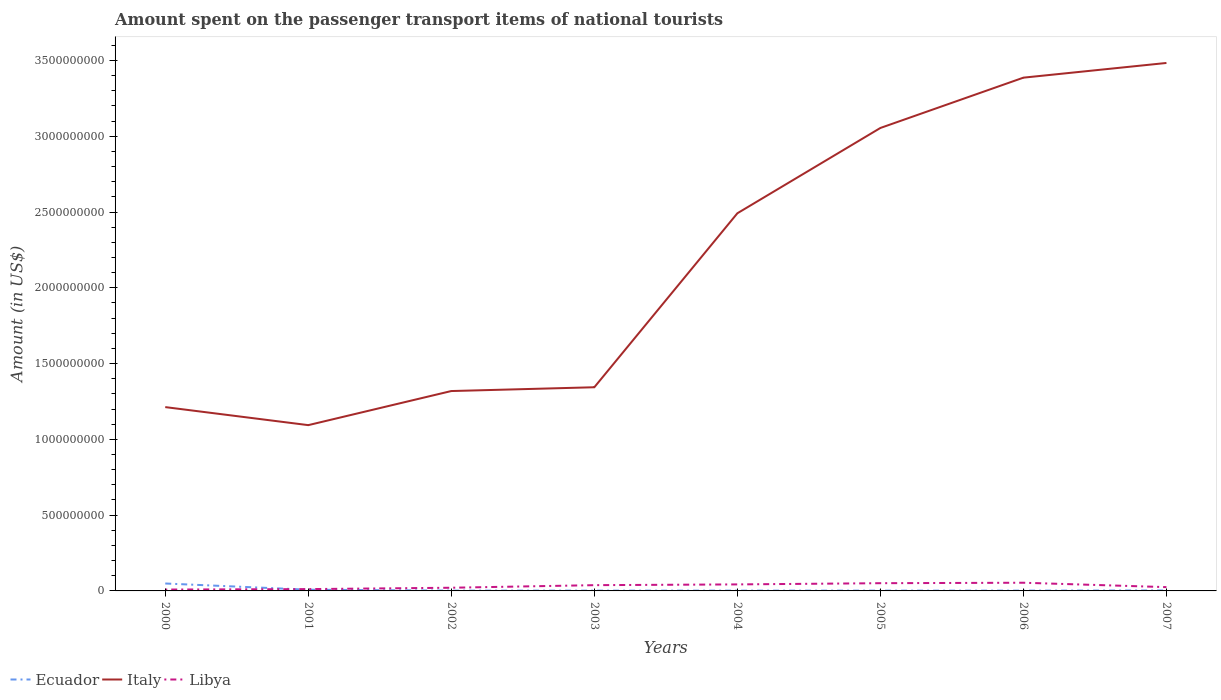Does the line corresponding to Libya intersect with the line corresponding to Italy?
Your answer should be very brief. No. Is the number of lines equal to the number of legend labels?
Your answer should be very brief. Yes. Across all years, what is the maximum amount spent on the passenger transport items of national tourists in Ecuador?
Give a very brief answer. 2.00e+06. What is the total amount spent on the passenger transport items of national tourists in Ecuador in the graph?
Keep it short and to the point. 6.00e+06. What is the difference between the highest and the second highest amount spent on the passenger transport items of national tourists in Ecuador?
Give a very brief answer. 4.70e+07. What is the difference between the highest and the lowest amount spent on the passenger transport items of national tourists in Libya?
Give a very brief answer. 4. How many lines are there?
Your answer should be very brief. 3. Does the graph contain any zero values?
Make the answer very short. No. Does the graph contain grids?
Offer a very short reply. No. Where does the legend appear in the graph?
Your answer should be compact. Bottom left. What is the title of the graph?
Provide a succinct answer. Amount spent on the passenger transport items of national tourists. Does "Austria" appear as one of the legend labels in the graph?
Make the answer very short. No. What is the label or title of the Y-axis?
Offer a terse response. Amount (in US$). What is the Amount (in US$) of Ecuador in 2000?
Your answer should be compact. 4.90e+07. What is the Amount (in US$) of Italy in 2000?
Keep it short and to the point. 1.21e+09. What is the Amount (in US$) in Libya in 2000?
Your answer should be very brief. 9.00e+06. What is the Amount (in US$) in Italy in 2001?
Provide a succinct answer. 1.09e+09. What is the Amount (in US$) in Ecuador in 2002?
Your response must be concise. 2.00e+06. What is the Amount (in US$) in Italy in 2002?
Provide a succinct answer. 1.32e+09. What is the Amount (in US$) in Libya in 2002?
Keep it short and to the point. 2.10e+07. What is the Amount (in US$) in Ecuador in 2003?
Your answer should be very brief. 2.00e+06. What is the Amount (in US$) in Italy in 2003?
Your answer should be compact. 1.34e+09. What is the Amount (in US$) of Libya in 2003?
Keep it short and to the point. 3.80e+07. What is the Amount (in US$) of Ecuador in 2004?
Provide a succinct answer. 2.00e+06. What is the Amount (in US$) in Italy in 2004?
Keep it short and to the point. 2.49e+09. What is the Amount (in US$) of Libya in 2004?
Your answer should be very brief. 4.30e+07. What is the Amount (in US$) of Italy in 2005?
Your answer should be very brief. 3.06e+09. What is the Amount (in US$) of Libya in 2005?
Give a very brief answer. 5.10e+07. What is the Amount (in US$) in Ecuador in 2006?
Your answer should be compact. 2.00e+06. What is the Amount (in US$) of Italy in 2006?
Keep it short and to the point. 3.39e+09. What is the Amount (in US$) of Libya in 2006?
Your response must be concise. 5.40e+07. What is the Amount (in US$) in Italy in 2007?
Make the answer very short. 3.48e+09. What is the Amount (in US$) in Libya in 2007?
Ensure brevity in your answer.  2.50e+07. Across all years, what is the maximum Amount (in US$) in Ecuador?
Keep it short and to the point. 4.90e+07. Across all years, what is the maximum Amount (in US$) of Italy?
Your response must be concise. 3.48e+09. Across all years, what is the maximum Amount (in US$) of Libya?
Make the answer very short. 5.40e+07. Across all years, what is the minimum Amount (in US$) of Ecuador?
Offer a terse response. 2.00e+06. Across all years, what is the minimum Amount (in US$) in Italy?
Your answer should be very brief. 1.09e+09. Across all years, what is the minimum Amount (in US$) in Libya?
Your answer should be compact. 9.00e+06. What is the total Amount (in US$) in Ecuador in the graph?
Keep it short and to the point. 7.00e+07. What is the total Amount (in US$) of Italy in the graph?
Offer a terse response. 1.74e+1. What is the total Amount (in US$) in Libya in the graph?
Provide a short and direct response. 2.53e+08. What is the difference between the Amount (in US$) of Ecuador in 2000 and that in 2001?
Offer a very short reply. 4.10e+07. What is the difference between the Amount (in US$) of Italy in 2000 and that in 2001?
Your answer should be compact. 1.19e+08. What is the difference between the Amount (in US$) in Ecuador in 2000 and that in 2002?
Give a very brief answer. 4.70e+07. What is the difference between the Amount (in US$) in Italy in 2000 and that in 2002?
Your answer should be compact. -1.06e+08. What is the difference between the Amount (in US$) of Libya in 2000 and that in 2002?
Offer a terse response. -1.20e+07. What is the difference between the Amount (in US$) of Ecuador in 2000 and that in 2003?
Give a very brief answer. 4.70e+07. What is the difference between the Amount (in US$) of Italy in 2000 and that in 2003?
Keep it short and to the point. -1.31e+08. What is the difference between the Amount (in US$) in Libya in 2000 and that in 2003?
Offer a very short reply. -2.90e+07. What is the difference between the Amount (in US$) of Ecuador in 2000 and that in 2004?
Keep it short and to the point. 4.70e+07. What is the difference between the Amount (in US$) of Italy in 2000 and that in 2004?
Offer a terse response. -1.28e+09. What is the difference between the Amount (in US$) in Libya in 2000 and that in 2004?
Provide a short and direct response. -3.40e+07. What is the difference between the Amount (in US$) in Ecuador in 2000 and that in 2005?
Give a very brief answer. 4.70e+07. What is the difference between the Amount (in US$) in Italy in 2000 and that in 2005?
Offer a very short reply. -1.84e+09. What is the difference between the Amount (in US$) of Libya in 2000 and that in 2005?
Your response must be concise. -4.20e+07. What is the difference between the Amount (in US$) of Ecuador in 2000 and that in 2006?
Give a very brief answer. 4.70e+07. What is the difference between the Amount (in US$) in Italy in 2000 and that in 2006?
Keep it short and to the point. -2.17e+09. What is the difference between the Amount (in US$) in Libya in 2000 and that in 2006?
Offer a terse response. -4.50e+07. What is the difference between the Amount (in US$) of Ecuador in 2000 and that in 2007?
Offer a very short reply. 4.60e+07. What is the difference between the Amount (in US$) of Italy in 2000 and that in 2007?
Your answer should be very brief. -2.27e+09. What is the difference between the Amount (in US$) in Libya in 2000 and that in 2007?
Provide a short and direct response. -1.60e+07. What is the difference between the Amount (in US$) in Italy in 2001 and that in 2002?
Your answer should be compact. -2.25e+08. What is the difference between the Amount (in US$) in Libya in 2001 and that in 2002?
Provide a succinct answer. -9.00e+06. What is the difference between the Amount (in US$) in Ecuador in 2001 and that in 2003?
Your answer should be compact. 6.00e+06. What is the difference between the Amount (in US$) of Italy in 2001 and that in 2003?
Your answer should be very brief. -2.50e+08. What is the difference between the Amount (in US$) in Libya in 2001 and that in 2003?
Give a very brief answer. -2.60e+07. What is the difference between the Amount (in US$) in Italy in 2001 and that in 2004?
Keep it short and to the point. -1.40e+09. What is the difference between the Amount (in US$) of Libya in 2001 and that in 2004?
Give a very brief answer. -3.10e+07. What is the difference between the Amount (in US$) in Ecuador in 2001 and that in 2005?
Give a very brief answer. 6.00e+06. What is the difference between the Amount (in US$) in Italy in 2001 and that in 2005?
Provide a short and direct response. -1.96e+09. What is the difference between the Amount (in US$) in Libya in 2001 and that in 2005?
Keep it short and to the point. -3.90e+07. What is the difference between the Amount (in US$) in Ecuador in 2001 and that in 2006?
Give a very brief answer. 6.00e+06. What is the difference between the Amount (in US$) in Italy in 2001 and that in 2006?
Keep it short and to the point. -2.29e+09. What is the difference between the Amount (in US$) in Libya in 2001 and that in 2006?
Your answer should be very brief. -4.20e+07. What is the difference between the Amount (in US$) of Italy in 2001 and that in 2007?
Keep it short and to the point. -2.39e+09. What is the difference between the Amount (in US$) of Libya in 2001 and that in 2007?
Your answer should be compact. -1.30e+07. What is the difference between the Amount (in US$) of Italy in 2002 and that in 2003?
Keep it short and to the point. -2.50e+07. What is the difference between the Amount (in US$) of Libya in 2002 and that in 2003?
Provide a succinct answer. -1.70e+07. What is the difference between the Amount (in US$) in Italy in 2002 and that in 2004?
Your answer should be compact. -1.17e+09. What is the difference between the Amount (in US$) in Libya in 2002 and that in 2004?
Make the answer very short. -2.20e+07. What is the difference between the Amount (in US$) of Italy in 2002 and that in 2005?
Ensure brevity in your answer.  -1.74e+09. What is the difference between the Amount (in US$) of Libya in 2002 and that in 2005?
Ensure brevity in your answer.  -3.00e+07. What is the difference between the Amount (in US$) of Italy in 2002 and that in 2006?
Give a very brief answer. -2.07e+09. What is the difference between the Amount (in US$) in Libya in 2002 and that in 2006?
Your answer should be compact. -3.30e+07. What is the difference between the Amount (in US$) of Italy in 2002 and that in 2007?
Offer a very short reply. -2.16e+09. What is the difference between the Amount (in US$) in Libya in 2002 and that in 2007?
Your response must be concise. -4.00e+06. What is the difference between the Amount (in US$) in Italy in 2003 and that in 2004?
Offer a very short reply. -1.15e+09. What is the difference between the Amount (in US$) in Libya in 2003 and that in 2004?
Give a very brief answer. -5.00e+06. What is the difference between the Amount (in US$) of Ecuador in 2003 and that in 2005?
Provide a succinct answer. 0. What is the difference between the Amount (in US$) of Italy in 2003 and that in 2005?
Your response must be concise. -1.71e+09. What is the difference between the Amount (in US$) in Libya in 2003 and that in 2005?
Ensure brevity in your answer.  -1.30e+07. What is the difference between the Amount (in US$) in Italy in 2003 and that in 2006?
Keep it short and to the point. -2.04e+09. What is the difference between the Amount (in US$) of Libya in 2003 and that in 2006?
Keep it short and to the point. -1.60e+07. What is the difference between the Amount (in US$) of Italy in 2003 and that in 2007?
Your response must be concise. -2.14e+09. What is the difference between the Amount (in US$) of Libya in 2003 and that in 2007?
Keep it short and to the point. 1.30e+07. What is the difference between the Amount (in US$) of Italy in 2004 and that in 2005?
Your answer should be very brief. -5.63e+08. What is the difference between the Amount (in US$) in Libya in 2004 and that in 2005?
Your answer should be compact. -8.00e+06. What is the difference between the Amount (in US$) in Italy in 2004 and that in 2006?
Your answer should be compact. -8.95e+08. What is the difference between the Amount (in US$) of Libya in 2004 and that in 2006?
Keep it short and to the point. -1.10e+07. What is the difference between the Amount (in US$) in Italy in 2004 and that in 2007?
Offer a very short reply. -9.92e+08. What is the difference between the Amount (in US$) of Libya in 2004 and that in 2007?
Offer a terse response. 1.80e+07. What is the difference between the Amount (in US$) of Italy in 2005 and that in 2006?
Offer a terse response. -3.32e+08. What is the difference between the Amount (in US$) of Italy in 2005 and that in 2007?
Provide a short and direct response. -4.29e+08. What is the difference between the Amount (in US$) of Libya in 2005 and that in 2007?
Your answer should be compact. 2.60e+07. What is the difference between the Amount (in US$) of Italy in 2006 and that in 2007?
Your answer should be very brief. -9.70e+07. What is the difference between the Amount (in US$) of Libya in 2006 and that in 2007?
Ensure brevity in your answer.  2.90e+07. What is the difference between the Amount (in US$) in Ecuador in 2000 and the Amount (in US$) in Italy in 2001?
Give a very brief answer. -1.04e+09. What is the difference between the Amount (in US$) in Ecuador in 2000 and the Amount (in US$) in Libya in 2001?
Your answer should be very brief. 3.70e+07. What is the difference between the Amount (in US$) in Italy in 2000 and the Amount (in US$) in Libya in 2001?
Make the answer very short. 1.20e+09. What is the difference between the Amount (in US$) in Ecuador in 2000 and the Amount (in US$) in Italy in 2002?
Provide a succinct answer. -1.27e+09. What is the difference between the Amount (in US$) in Ecuador in 2000 and the Amount (in US$) in Libya in 2002?
Keep it short and to the point. 2.80e+07. What is the difference between the Amount (in US$) in Italy in 2000 and the Amount (in US$) in Libya in 2002?
Make the answer very short. 1.19e+09. What is the difference between the Amount (in US$) in Ecuador in 2000 and the Amount (in US$) in Italy in 2003?
Offer a terse response. -1.30e+09. What is the difference between the Amount (in US$) of Ecuador in 2000 and the Amount (in US$) of Libya in 2003?
Your answer should be compact. 1.10e+07. What is the difference between the Amount (in US$) in Italy in 2000 and the Amount (in US$) in Libya in 2003?
Make the answer very short. 1.18e+09. What is the difference between the Amount (in US$) in Ecuador in 2000 and the Amount (in US$) in Italy in 2004?
Ensure brevity in your answer.  -2.44e+09. What is the difference between the Amount (in US$) in Ecuador in 2000 and the Amount (in US$) in Libya in 2004?
Provide a short and direct response. 6.00e+06. What is the difference between the Amount (in US$) in Italy in 2000 and the Amount (in US$) in Libya in 2004?
Make the answer very short. 1.17e+09. What is the difference between the Amount (in US$) in Ecuador in 2000 and the Amount (in US$) in Italy in 2005?
Provide a succinct answer. -3.01e+09. What is the difference between the Amount (in US$) of Ecuador in 2000 and the Amount (in US$) of Libya in 2005?
Your answer should be compact. -2.00e+06. What is the difference between the Amount (in US$) of Italy in 2000 and the Amount (in US$) of Libya in 2005?
Offer a very short reply. 1.16e+09. What is the difference between the Amount (in US$) in Ecuador in 2000 and the Amount (in US$) in Italy in 2006?
Ensure brevity in your answer.  -3.34e+09. What is the difference between the Amount (in US$) of Ecuador in 2000 and the Amount (in US$) of Libya in 2006?
Make the answer very short. -5.00e+06. What is the difference between the Amount (in US$) of Italy in 2000 and the Amount (in US$) of Libya in 2006?
Your answer should be compact. 1.16e+09. What is the difference between the Amount (in US$) in Ecuador in 2000 and the Amount (in US$) in Italy in 2007?
Your answer should be compact. -3.44e+09. What is the difference between the Amount (in US$) in Ecuador in 2000 and the Amount (in US$) in Libya in 2007?
Provide a short and direct response. 2.40e+07. What is the difference between the Amount (in US$) of Italy in 2000 and the Amount (in US$) of Libya in 2007?
Offer a very short reply. 1.19e+09. What is the difference between the Amount (in US$) of Ecuador in 2001 and the Amount (in US$) of Italy in 2002?
Your response must be concise. -1.31e+09. What is the difference between the Amount (in US$) of Ecuador in 2001 and the Amount (in US$) of Libya in 2002?
Your answer should be compact. -1.30e+07. What is the difference between the Amount (in US$) of Italy in 2001 and the Amount (in US$) of Libya in 2002?
Make the answer very short. 1.07e+09. What is the difference between the Amount (in US$) in Ecuador in 2001 and the Amount (in US$) in Italy in 2003?
Offer a very short reply. -1.34e+09. What is the difference between the Amount (in US$) in Ecuador in 2001 and the Amount (in US$) in Libya in 2003?
Provide a succinct answer. -3.00e+07. What is the difference between the Amount (in US$) of Italy in 2001 and the Amount (in US$) of Libya in 2003?
Keep it short and to the point. 1.06e+09. What is the difference between the Amount (in US$) in Ecuador in 2001 and the Amount (in US$) in Italy in 2004?
Ensure brevity in your answer.  -2.48e+09. What is the difference between the Amount (in US$) in Ecuador in 2001 and the Amount (in US$) in Libya in 2004?
Keep it short and to the point. -3.50e+07. What is the difference between the Amount (in US$) of Italy in 2001 and the Amount (in US$) of Libya in 2004?
Provide a short and direct response. 1.05e+09. What is the difference between the Amount (in US$) in Ecuador in 2001 and the Amount (in US$) in Italy in 2005?
Offer a terse response. -3.05e+09. What is the difference between the Amount (in US$) of Ecuador in 2001 and the Amount (in US$) of Libya in 2005?
Offer a terse response. -4.30e+07. What is the difference between the Amount (in US$) in Italy in 2001 and the Amount (in US$) in Libya in 2005?
Make the answer very short. 1.04e+09. What is the difference between the Amount (in US$) of Ecuador in 2001 and the Amount (in US$) of Italy in 2006?
Your answer should be compact. -3.38e+09. What is the difference between the Amount (in US$) in Ecuador in 2001 and the Amount (in US$) in Libya in 2006?
Your answer should be compact. -4.60e+07. What is the difference between the Amount (in US$) of Italy in 2001 and the Amount (in US$) of Libya in 2006?
Provide a short and direct response. 1.04e+09. What is the difference between the Amount (in US$) in Ecuador in 2001 and the Amount (in US$) in Italy in 2007?
Your answer should be very brief. -3.48e+09. What is the difference between the Amount (in US$) of Ecuador in 2001 and the Amount (in US$) of Libya in 2007?
Offer a very short reply. -1.70e+07. What is the difference between the Amount (in US$) of Italy in 2001 and the Amount (in US$) of Libya in 2007?
Keep it short and to the point. 1.07e+09. What is the difference between the Amount (in US$) of Ecuador in 2002 and the Amount (in US$) of Italy in 2003?
Ensure brevity in your answer.  -1.34e+09. What is the difference between the Amount (in US$) of Ecuador in 2002 and the Amount (in US$) of Libya in 2003?
Offer a very short reply. -3.60e+07. What is the difference between the Amount (in US$) of Italy in 2002 and the Amount (in US$) of Libya in 2003?
Provide a short and direct response. 1.28e+09. What is the difference between the Amount (in US$) of Ecuador in 2002 and the Amount (in US$) of Italy in 2004?
Provide a succinct answer. -2.49e+09. What is the difference between the Amount (in US$) in Ecuador in 2002 and the Amount (in US$) in Libya in 2004?
Give a very brief answer. -4.10e+07. What is the difference between the Amount (in US$) of Italy in 2002 and the Amount (in US$) of Libya in 2004?
Your answer should be very brief. 1.28e+09. What is the difference between the Amount (in US$) in Ecuador in 2002 and the Amount (in US$) in Italy in 2005?
Your response must be concise. -3.05e+09. What is the difference between the Amount (in US$) of Ecuador in 2002 and the Amount (in US$) of Libya in 2005?
Make the answer very short. -4.90e+07. What is the difference between the Amount (in US$) of Italy in 2002 and the Amount (in US$) of Libya in 2005?
Your response must be concise. 1.27e+09. What is the difference between the Amount (in US$) in Ecuador in 2002 and the Amount (in US$) in Italy in 2006?
Ensure brevity in your answer.  -3.38e+09. What is the difference between the Amount (in US$) in Ecuador in 2002 and the Amount (in US$) in Libya in 2006?
Provide a succinct answer. -5.20e+07. What is the difference between the Amount (in US$) of Italy in 2002 and the Amount (in US$) of Libya in 2006?
Give a very brief answer. 1.26e+09. What is the difference between the Amount (in US$) in Ecuador in 2002 and the Amount (in US$) in Italy in 2007?
Keep it short and to the point. -3.48e+09. What is the difference between the Amount (in US$) in Ecuador in 2002 and the Amount (in US$) in Libya in 2007?
Offer a terse response. -2.30e+07. What is the difference between the Amount (in US$) of Italy in 2002 and the Amount (in US$) of Libya in 2007?
Your response must be concise. 1.29e+09. What is the difference between the Amount (in US$) in Ecuador in 2003 and the Amount (in US$) in Italy in 2004?
Offer a very short reply. -2.49e+09. What is the difference between the Amount (in US$) of Ecuador in 2003 and the Amount (in US$) of Libya in 2004?
Keep it short and to the point. -4.10e+07. What is the difference between the Amount (in US$) in Italy in 2003 and the Amount (in US$) in Libya in 2004?
Your answer should be very brief. 1.30e+09. What is the difference between the Amount (in US$) in Ecuador in 2003 and the Amount (in US$) in Italy in 2005?
Ensure brevity in your answer.  -3.05e+09. What is the difference between the Amount (in US$) of Ecuador in 2003 and the Amount (in US$) of Libya in 2005?
Your answer should be very brief. -4.90e+07. What is the difference between the Amount (in US$) of Italy in 2003 and the Amount (in US$) of Libya in 2005?
Your response must be concise. 1.29e+09. What is the difference between the Amount (in US$) of Ecuador in 2003 and the Amount (in US$) of Italy in 2006?
Offer a terse response. -3.38e+09. What is the difference between the Amount (in US$) of Ecuador in 2003 and the Amount (in US$) of Libya in 2006?
Your answer should be compact. -5.20e+07. What is the difference between the Amount (in US$) in Italy in 2003 and the Amount (in US$) in Libya in 2006?
Make the answer very short. 1.29e+09. What is the difference between the Amount (in US$) in Ecuador in 2003 and the Amount (in US$) in Italy in 2007?
Offer a very short reply. -3.48e+09. What is the difference between the Amount (in US$) in Ecuador in 2003 and the Amount (in US$) in Libya in 2007?
Offer a terse response. -2.30e+07. What is the difference between the Amount (in US$) in Italy in 2003 and the Amount (in US$) in Libya in 2007?
Give a very brief answer. 1.32e+09. What is the difference between the Amount (in US$) of Ecuador in 2004 and the Amount (in US$) of Italy in 2005?
Make the answer very short. -3.05e+09. What is the difference between the Amount (in US$) in Ecuador in 2004 and the Amount (in US$) in Libya in 2005?
Ensure brevity in your answer.  -4.90e+07. What is the difference between the Amount (in US$) in Italy in 2004 and the Amount (in US$) in Libya in 2005?
Keep it short and to the point. 2.44e+09. What is the difference between the Amount (in US$) of Ecuador in 2004 and the Amount (in US$) of Italy in 2006?
Keep it short and to the point. -3.38e+09. What is the difference between the Amount (in US$) in Ecuador in 2004 and the Amount (in US$) in Libya in 2006?
Make the answer very short. -5.20e+07. What is the difference between the Amount (in US$) in Italy in 2004 and the Amount (in US$) in Libya in 2006?
Offer a terse response. 2.44e+09. What is the difference between the Amount (in US$) of Ecuador in 2004 and the Amount (in US$) of Italy in 2007?
Offer a very short reply. -3.48e+09. What is the difference between the Amount (in US$) of Ecuador in 2004 and the Amount (in US$) of Libya in 2007?
Your answer should be very brief. -2.30e+07. What is the difference between the Amount (in US$) in Italy in 2004 and the Amount (in US$) in Libya in 2007?
Keep it short and to the point. 2.47e+09. What is the difference between the Amount (in US$) of Ecuador in 2005 and the Amount (in US$) of Italy in 2006?
Ensure brevity in your answer.  -3.38e+09. What is the difference between the Amount (in US$) in Ecuador in 2005 and the Amount (in US$) in Libya in 2006?
Offer a terse response. -5.20e+07. What is the difference between the Amount (in US$) of Italy in 2005 and the Amount (in US$) of Libya in 2006?
Your answer should be very brief. 3.00e+09. What is the difference between the Amount (in US$) in Ecuador in 2005 and the Amount (in US$) in Italy in 2007?
Provide a short and direct response. -3.48e+09. What is the difference between the Amount (in US$) of Ecuador in 2005 and the Amount (in US$) of Libya in 2007?
Provide a succinct answer. -2.30e+07. What is the difference between the Amount (in US$) of Italy in 2005 and the Amount (in US$) of Libya in 2007?
Your response must be concise. 3.03e+09. What is the difference between the Amount (in US$) in Ecuador in 2006 and the Amount (in US$) in Italy in 2007?
Give a very brief answer. -3.48e+09. What is the difference between the Amount (in US$) in Ecuador in 2006 and the Amount (in US$) in Libya in 2007?
Offer a very short reply. -2.30e+07. What is the difference between the Amount (in US$) in Italy in 2006 and the Amount (in US$) in Libya in 2007?
Provide a short and direct response. 3.36e+09. What is the average Amount (in US$) in Ecuador per year?
Offer a very short reply. 8.75e+06. What is the average Amount (in US$) of Italy per year?
Provide a succinct answer. 2.17e+09. What is the average Amount (in US$) of Libya per year?
Your response must be concise. 3.16e+07. In the year 2000, what is the difference between the Amount (in US$) in Ecuador and Amount (in US$) in Italy?
Provide a succinct answer. -1.16e+09. In the year 2000, what is the difference between the Amount (in US$) in Ecuador and Amount (in US$) in Libya?
Your answer should be very brief. 4.00e+07. In the year 2000, what is the difference between the Amount (in US$) of Italy and Amount (in US$) of Libya?
Offer a very short reply. 1.20e+09. In the year 2001, what is the difference between the Amount (in US$) of Ecuador and Amount (in US$) of Italy?
Offer a very short reply. -1.09e+09. In the year 2001, what is the difference between the Amount (in US$) in Italy and Amount (in US$) in Libya?
Ensure brevity in your answer.  1.08e+09. In the year 2002, what is the difference between the Amount (in US$) in Ecuador and Amount (in US$) in Italy?
Offer a very short reply. -1.32e+09. In the year 2002, what is the difference between the Amount (in US$) in Ecuador and Amount (in US$) in Libya?
Your response must be concise. -1.90e+07. In the year 2002, what is the difference between the Amount (in US$) of Italy and Amount (in US$) of Libya?
Your answer should be very brief. 1.30e+09. In the year 2003, what is the difference between the Amount (in US$) of Ecuador and Amount (in US$) of Italy?
Provide a succinct answer. -1.34e+09. In the year 2003, what is the difference between the Amount (in US$) in Ecuador and Amount (in US$) in Libya?
Make the answer very short. -3.60e+07. In the year 2003, what is the difference between the Amount (in US$) of Italy and Amount (in US$) of Libya?
Make the answer very short. 1.31e+09. In the year 2004, what is the difference between the Amount (in US$) in Ecuador and Amount (in US$) in Italy?
Provide a succinct answer. -2.49e+09. In the year 2004, what is the difference between the Amount (in US$) of Ecuador and Amount (in US$) of Libya?
Keep it short and to the point. -4.10e+07. In the year 2004, what is the difference between the Amount (in US$) in Italy and Amount (in US$) in Libya?
Offer a very short reply. 2.45e+09. In the year 2005, what is the difference between the Amount (in US$) in Ecuador and Amount (in US$) in Italy?
Provide a short and direct response. -3.05e+09. In the year 2005, what is the difference between the Amount (in US$) of Ecuador and Amount (in US$) of Libya?
Provide a short and direct response. -4.90e+07. In the year 2005, what is the difference between the Amount (in US$) in Italy and Amount (in US$) in Libya?
Make the answer very short. 3.00e+09. In the year 2006, what is the difference between the Amount (in US$) of Ecuador and Amount (in US$) of Italy?
Your answer should be compact. -3.38e+09. In the year 2006, what is the difference between the Amount (in US$) of Ecuador and Amount (in US$) of Libya?
Your answer should be compact. -5.20e+07. In the year 2006, what is the difference between the Amount (in US$) of Italy and Amount (in US$) of Libya?
Ensure brevity in your answer.  3.33e+09. In the year 2007, what is the difference between the Amount (in US$) of Ecuador and Amount (in US$) of Italy?
Keep it short and to the point. -3.48e+09. In the year 2007, what is the difference between the Amount (in US$) of Ecuador and Amount (in US$) of Libya?
Your answer should be compact. -2.20e+07. In the year 2007, what is the difference between the Amount (in US$) in Italy and Amount (in US$) in Libya?
Give a very brief answer. 3.46e+09. What is the ratio of the Amount (in US$) of Ecuador in 2000 to that in 2001?
Give a very brief answer. 6.12. What is the ratio of the Amount (in US$) of Italy in 2000 to that in 2001?
Your answer should be very brief. 1.11. What is the ratio of the Amount (in US$) in Libya in 2000 to that in 2001?
Keep it short and to the point. 0.75. What is the ratio of the Amount (in US$) in Ecuador in 2000 to that in 2002?
Give a very brief answer. 24.5. What is the ratio of the Amount (in US$) of Italy in 2000 to that in 2002?
Your answer should be compact. 0.92. What is the ratio of the Amount (in US$) in Libya in 2000 to that in 2002?
Your answer should be very brief. 0.43. What is the ratio of the Amount (in US$) of Ecuador in 2000 to that in 2003?
Provide a short and direct response. 24.5. What is the ratio of the Amount (in US$) of Italy in 2000 to that in 2003?
Provide a succinct answer. 0.9. What is the ratio of the Amount (in US$) of Libya in 2000 to that in 2003?
Offer a very short reply. 0.24. What is the ratio of the Amount (in US$) of Ecuador in 2000 to that in 2004?
Make the answer very short. 24.5. What is the ratio of the Amount (in US$) of Italy in 2000 to that in 2004?
Your answer should be very brief. 0.49. What is the ratio of the Amount (in US$) of Libya in 2000 to that in 2004?
Offer a terse response. 0.21. What is the ratio of the Amount (in US$) in Ecuador in 2000 to that in 2005?
Make the answer very short. 24.5. What is the ratio of the Amount (in US$) in Italy in 2000 to that in 2005?
Ensure brevity in your answer.  0.4. What is the ratio of the Amount (in US$) of Libya in 2000 to that in 2005?
Provide a succinct answer. 0.18. What is the ratio of the Amount (in US$) of Ecuador in 2000 to that in 2006?
Offer a terse response. 24.5. What is the ratio of the Amount (in US$) of Italy in 2000 to that in 2006?
Provide a short and direct response. 0.36. What is the ratio of the Amount (in US$) of Libya in 2000 to that in 2006?
Offer a terse response. 0.17. What is the ratio of the Amount (in US$) of Ecuador in 2000 to that in 2007?
Ensure brevity in your answer.  16.33. What is the ratio of the Amount (in US$) in Italy in 2000 to that in 2007?
Offer a very short reply. 0.35. What is the ratio of the Amount (in US$) of Libya in 2000 to that in 2007?
Your answer should be very brief. 0.36. What is the ratio of the Amount (in US$) in Ecuador in 2001 to that in 2002?
Make the answer very short. 4. What is the ratio of the Amount (in US$) of Italy in 2001 to that in 2002?
Offer a very short reply. 0.83. What is the ratio of the Amount (in US$) of Italy in 2001 to that in 2003?
Your response must be concise. 0.81. What is the ratio of the Amount (in US$) of Libya in 2001 to that in 2003?
Provide a succinct answer. 0.32. What is the ratio of the Amount (in US$) in Ecuador in 2001 to that in 2004?
Make the answer very short. 4. What is the ratio of the Amount (in US$) in Italy in 2001 to that in 2004?
Your answer should be compact. 0.44. What is the ratio of the Amount (in US$) of Libya in 2001 to that in 2004?
Ensure brevity in your answer.  0.28. What is the ratio of the Amount (in US$) in Ecuador in 2001 to that in 2005?
Make the answer very short. 4. What is the ratio of the Amount (in US$) of Italy in 2001 to that in 2005?
Make the answer very short. 0.36. What is the ratio of the Amount (in US$) in Libya in 2001 to that in 2005?
Give a very brief answer. 0.24. What is the ratio of the Amount (in US$) in Italy in 2001 to that in 2006?
Ensure brevity in your answer.  0.32. What is the ratio of the Amount (in US$) of Libya in 2001 to that in 2006?
Your response must be concise. 0.22. What is the ratio of the Amount (in US$) of Ecuador in 2001 to that in 2007?
Offer a very short reply. 2.67. What is the ratio of the Amount (in US$) of Italy in 2001 to that in 2007?
Your answer should be very brief. 0.31. What is the ratio of the Amount (in US$) of Libya in 2001 to that in 2007?
Provide a succinct answer. 0.48. What is the ratio of the Amount (in US$) of Ecuador in 2002 to that in 2003?
Make the answer very short. 1. What is the ratio of the Amount (in US$) of Italy in 2002 to that in 2003?
Provide a succinct answer. 0.98. What is the ratio of the Amount (in US$) in Libya in 2002 to that in 2003?
Offer a terse response. 0.55. What is the ratio of the Amount (in US$) of Italy in 2002 to that in 2004?
Provide a short and direct response. 0.53. What is the ratio of the Amount (in US$) in Libya in 2002 to that in 2004?
Provide a succinct answer. 0.49. What is the ratio of the Amount (in US$) of Ecuador in 2002 to that in 2005?
Your response must be concise. 1. What is the ratio of the Amount (in US$) in Italy in 2002 to that in 2005?
Give a very brief answer. 0.43. What is the ratio of the Amount (in US$) in Libya in 2002 to that in 2005?
Offer a very short reply. 0.41. What is the ratio of the Amount (in US$) of Ecuador in 2002 to that in 2006?
Your answer should be very brief. 1. What is the ratio of the Amount (in US$) of Italy in 2002 to that in 2006?
Provide a short and direct response. 0.39. What is the ratio of the Amount (in US$) in Libya in 2002 to that in 2006?
Ensure brevity in your answer.  0.39. What is the ratio of the Amount (in US$) in Italy in 2002 to that in 2007?
Keep it short and to the point. 0.38. What is the ratio of the Amount (in US$) in Libya in 2002 to that in 2007?
Offer a very short reply. 0.84. What is the ratio of the Amount (in US$) of Ecuador in 2003 to that in 2004?
Your answer should be compact. 1. What is the ratio of the Amount (in US$) in Italy in 2003 to that in 2004?
Provide a succinct answer. 0.54. What is the ratio of the Amount (in US$) in Libya in 2003 to that in 2004?
Provide a succinct answer. 0.88. What is the ratio of the Amount (in US$) of Ecuador in 2003 to that in 2005?
Your answer should be very brief. 1. What is the ratio of the Amount (in US$) of Italy in 2003 to that in 2005?
Offer a very short reply. 0.44. What is the ratio of the Amount (in US$) of Libya in 2003 to that in 2005?
Your answer should be very brief. 0.75. What is the ratio of the Amount (in US$) in Ecuador in 2003 to that in 2006?
Provide a succinct answer. 1. What is the ratio of the Amount (in US$) in Italy in 2003 to that in 2006?
Offer a very short reply. 0.4. What is the ratio of the Amount (in US$) of Libya in 2003 to that in 2006?
Offer a very short reply. 0.7. What is the ratio of the Amount (in US$) of Italy in 2003 to that in 2007?
Make the answer very short. 0.39. What is the ratio of the Amount (in US$) in Libya in 2003 to that in 2007?
Keep it short and to the point. 1.52. What is the ratio of the Amount (in US$) of Ecuador in 2004 to that in 2005?
Your answer should be compact. 1. What is the ratio of the Amount (in US$) of Italy in 2004 to that in 2005?
Offer a very short reply. 0.82. What is the ratio of the Amount (in US$) of Libya in 2004 to that in 2005?
Make the answer very short. 0.84. What is the ratio of the Amount (in US$) of Italy in 2004 to that in 2006?
Ensure brevity in your answer.  0.74. What is the ratio of the Amount (in US$) in Libya in 2004 to that in 2006?
Provide a succinct answer. 0.8. What is the ratio of the Amount (in US$) in Ecuador in 2004 to that in 2007?
Your answer should be very brief. 0.67. What is the ratio of the Amount (in US$) in Italy in 2004 to that in 2007?
Keep it short and to the point. 0.72. What is the ratio of the Amount (in US$) in Libya in 2004 to that in 2007?
Offer a terse response. 1.72. What is the ratio of the Amount (in US$) of Ecuador in 2005 to that in 2006?
Give a very brief answer. 1. What is the ratio of the Amount (in US$) in Italy in 2005 to that in 2006?
Make the answer very short. 0.9. What is the ratio of the Amount (in US$) of Italy in 2005 to that in 2007?
Give a very brief answer. 0.88. What is the ratio of the Amount (in US$) in Libya in 2005 to that in 2007?
Offer a terse response. 2.04. What is the ratio of the Amount (in US$) of Italy in 2006 to that in 2007?
Offer a very short reply. 0.97. What is the ratio of the Amount (in US$) of Libya in 2006 to that in 2007?
Make the answer very short. 2.16. What is the difference between the highest and the second highest Amount (in US$) in Ecuador?
Provide a short and direct response. 4.10e+07. What is the difference between the highest and the second highest Amount (in US$) of Italy?
Your response must be concise. 9.70e+07. What is the difference between the highest and the second highest Amount (in US$) in Libya?
Ensure brevity in your answer.  3.00e+06. What is the difference between the highest and the lowest Amount (in US$) in Ecuador?
Offer a terse response. 4.70e+07. What is the difference between the highest and the lowest Amount (in US$) of Italy?
Offer a terse response. 2.39e+09. What is the difference between the highest and the lowest Amount (in US$) of Libya?
Make the answer very short. 4.50e+07. 